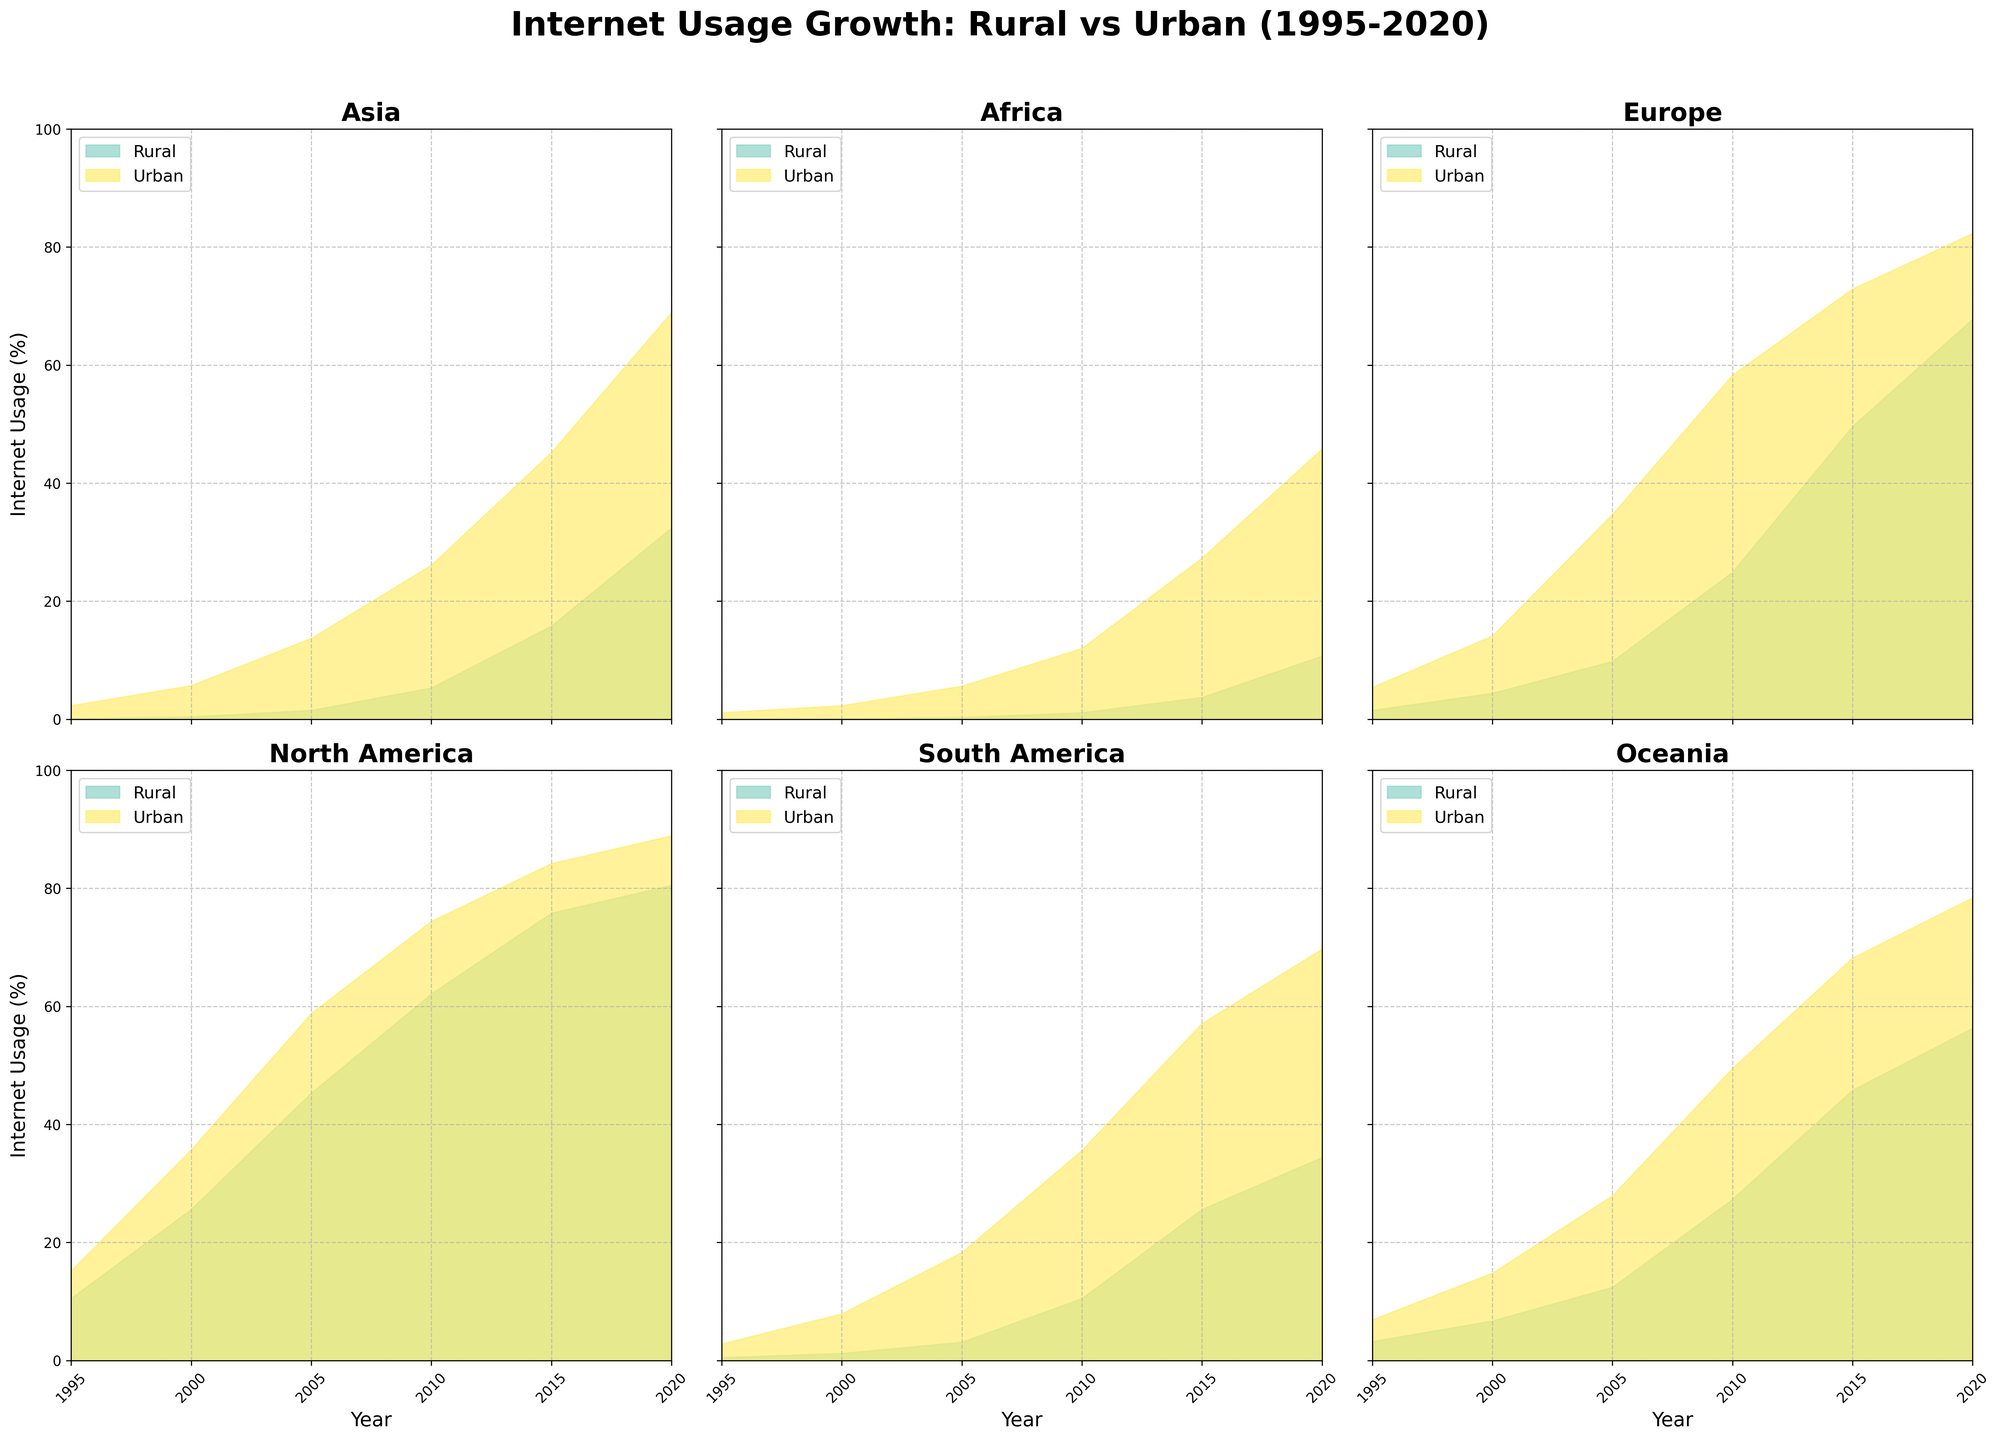What is the title of the figure? The title of the figure is prominently displayed at the top of the multiple subplots.
Answer: Internet Usage Growth: Rural vs Urban (1995-2020) How does rural internet usage in Asia change from 1995 to 2020? The area chart for Asia shows that rural internet usage starts at 0.1% in 1995 and gradually increases over the years, reaching 32.4% in 2020.
Answer: Increases from 0.1% to 32.4% Which region had the highest urban internet usage percentage in 2000? By looking at each subplot and focusing on the urban areas for the year 2000, North America stands out with the highest urban internet usage of 35.7%.
Answer: North America In 2010, which area (rural or urban) in Europe had a larger increase in internet usage compared to 2005? In the Europe subplot, the rural area increases from 9.8% in 2005 to 24.9% in 2010, while the urban area grows from 34.7% to 58.3%. Calculating the differences, rural (15.1%) and urban (23.6%), urban has the larger increase.
Answer: Urban What was the internet usage percentage in South American rural areas in 1995? The South American subplot shows the rural area usage in 1995 as 0.5%.
Answer: 0.5% How does the internet usage gap between rural and urban areas in Oceania change from 1995 to 2020? In Oceania, the gap in 1995 is 3.7% (urban 6.9% - rural 3.2%), and it becomes 22.1% (urban 78.4% - rural 56.3%) in 2020. Thus, the gap increases significantly over the period.
Answer: Increases from 3.7% to 22.1% Which region had the smallest growth in rural internet usage from 1995 to 2020? By comparing the rural internet usage growth across all regions, Africa shows the smallest growth, increasing from 0.0% in 1995 to 10.7% in 2020.
Answer: Africa In which year did urban areas in North America reach over 80% internet usage? Observing the North America subplot, urban areas reached over 80% internet usage in the year 2015 (84.2%).
Answer: 2015 Between 2005 and 2010, which continent saw a more significant increase in rural internet usage: Asia or Africa? Asia's rural internet usage increased from 1.5% in 2005 to 5.3% in 2010 (3.8% increase), while Africa's increased from 0.3% to 1.1% (0.8% increase). Thus, Asia saw a more significant increase.
Answer: Asia What is the trend for urban internet usage in South America from 1995 to 2020? The South America subplot shows a clear upward trend in urban internet usage, starting from 2.8% in 1995 and steadily increasing to 69.7% by 2020.
Answer: Increasing trend 